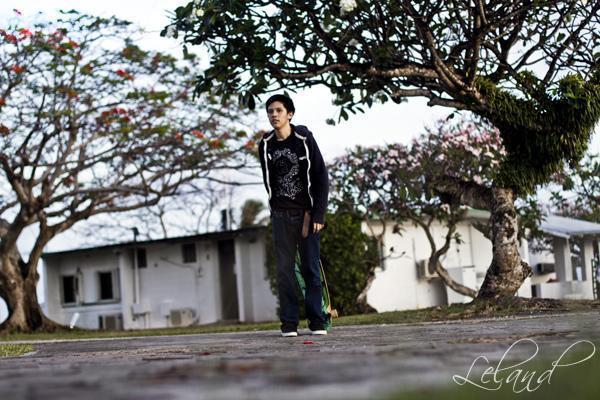How many windows?
Give a very brief answer. 4. 